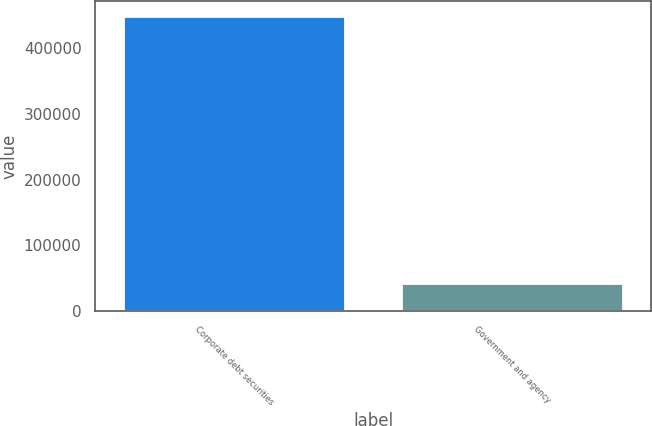<chart> <loc_0><loc_0><loc_500><loc_500><bar_chart><fcel>Corporate debt securities<fcel>Government and agency<nl><fcel>448495<fcel>42086<nl></chart> 